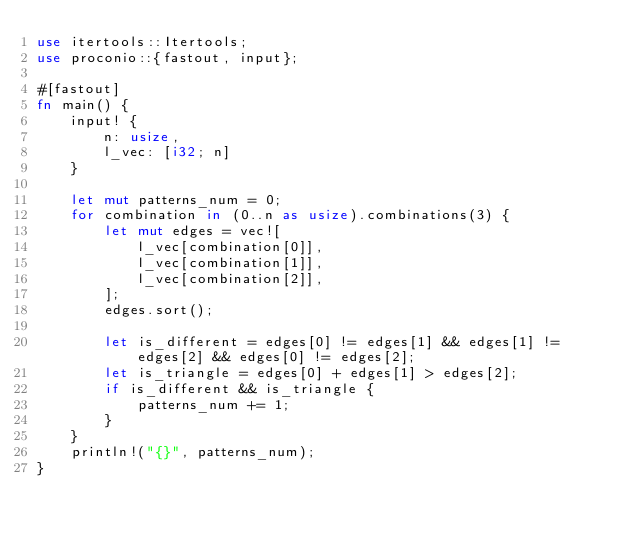Convert code to text. <code><loc_0><loc_0><loc_500><loc_500><_Rust_>use itertools::Itertools;
use proconio::{fastout, input};

#[fastout]
fn main() {
    input! {
        n: usize,
        l_vec: [i32; n]
    }

    let mut patterns_num = 0;
    for combination in (0..n as usize).combinations(3) {
        let mut edges = vec![
            l_vec[combination[0]],
            l_vec[combination[1]],
            l_vec[combination[2]],
        ];
        edges.sort();

        let is_different = edges[0] != edges[1] && edges[1] != edges[2] && edges[0] != edges[2];
        let is_triangle = edges[0] + edges[1] > edges[2];
        if is_different && is_triangle {
            patterns_num += 1;
        }
    }
    println!("{}", patterns_num);
}
</code> 